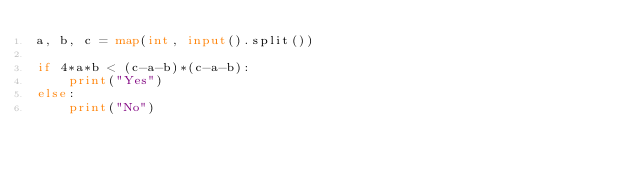<code> <loc_0><loc_0><loc_500><loc_500><_Python_>a, b, c = map(int, input().split())

if 4*a*b < (c-a-b)*(c-a-b):
    print("Yes")
else:
    print("No")</code> 